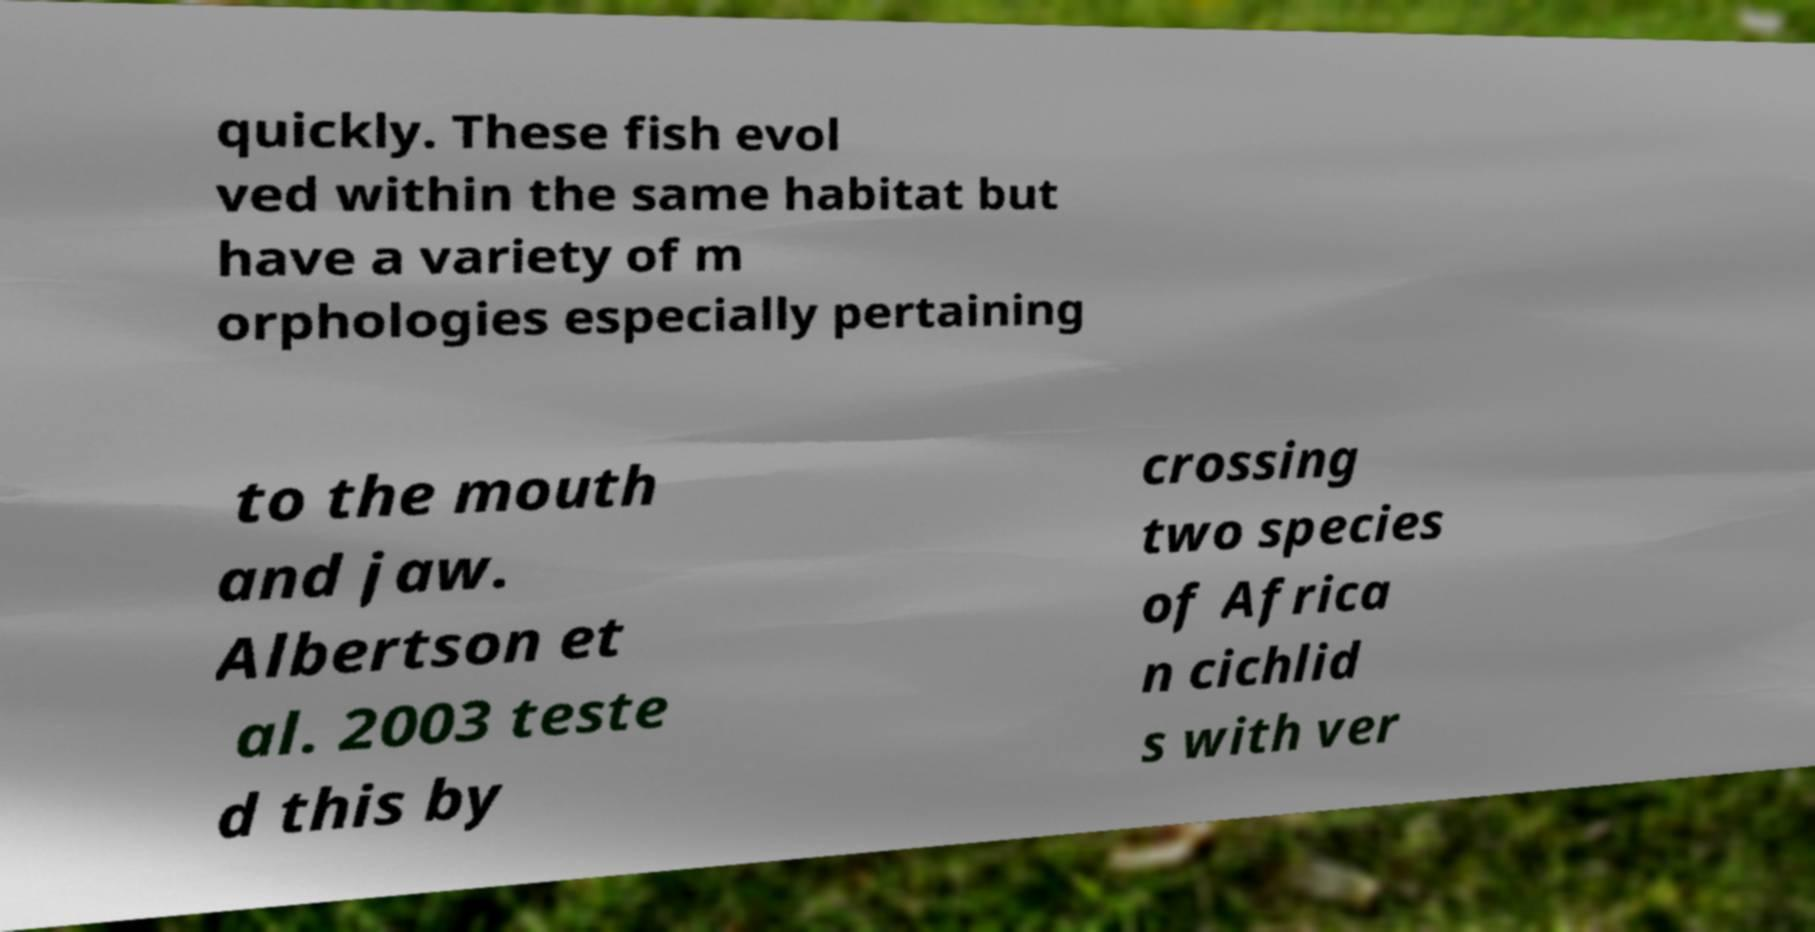Can you accurately transcribe the text from the provided image for me? quickly. These fish evol ved within the same habitat but have a variety of m orphologies especially pertaining to the mouth and jaw. Albertson et al. 2003 teste d this by crossing two species of Africa n cichlid s with ver 